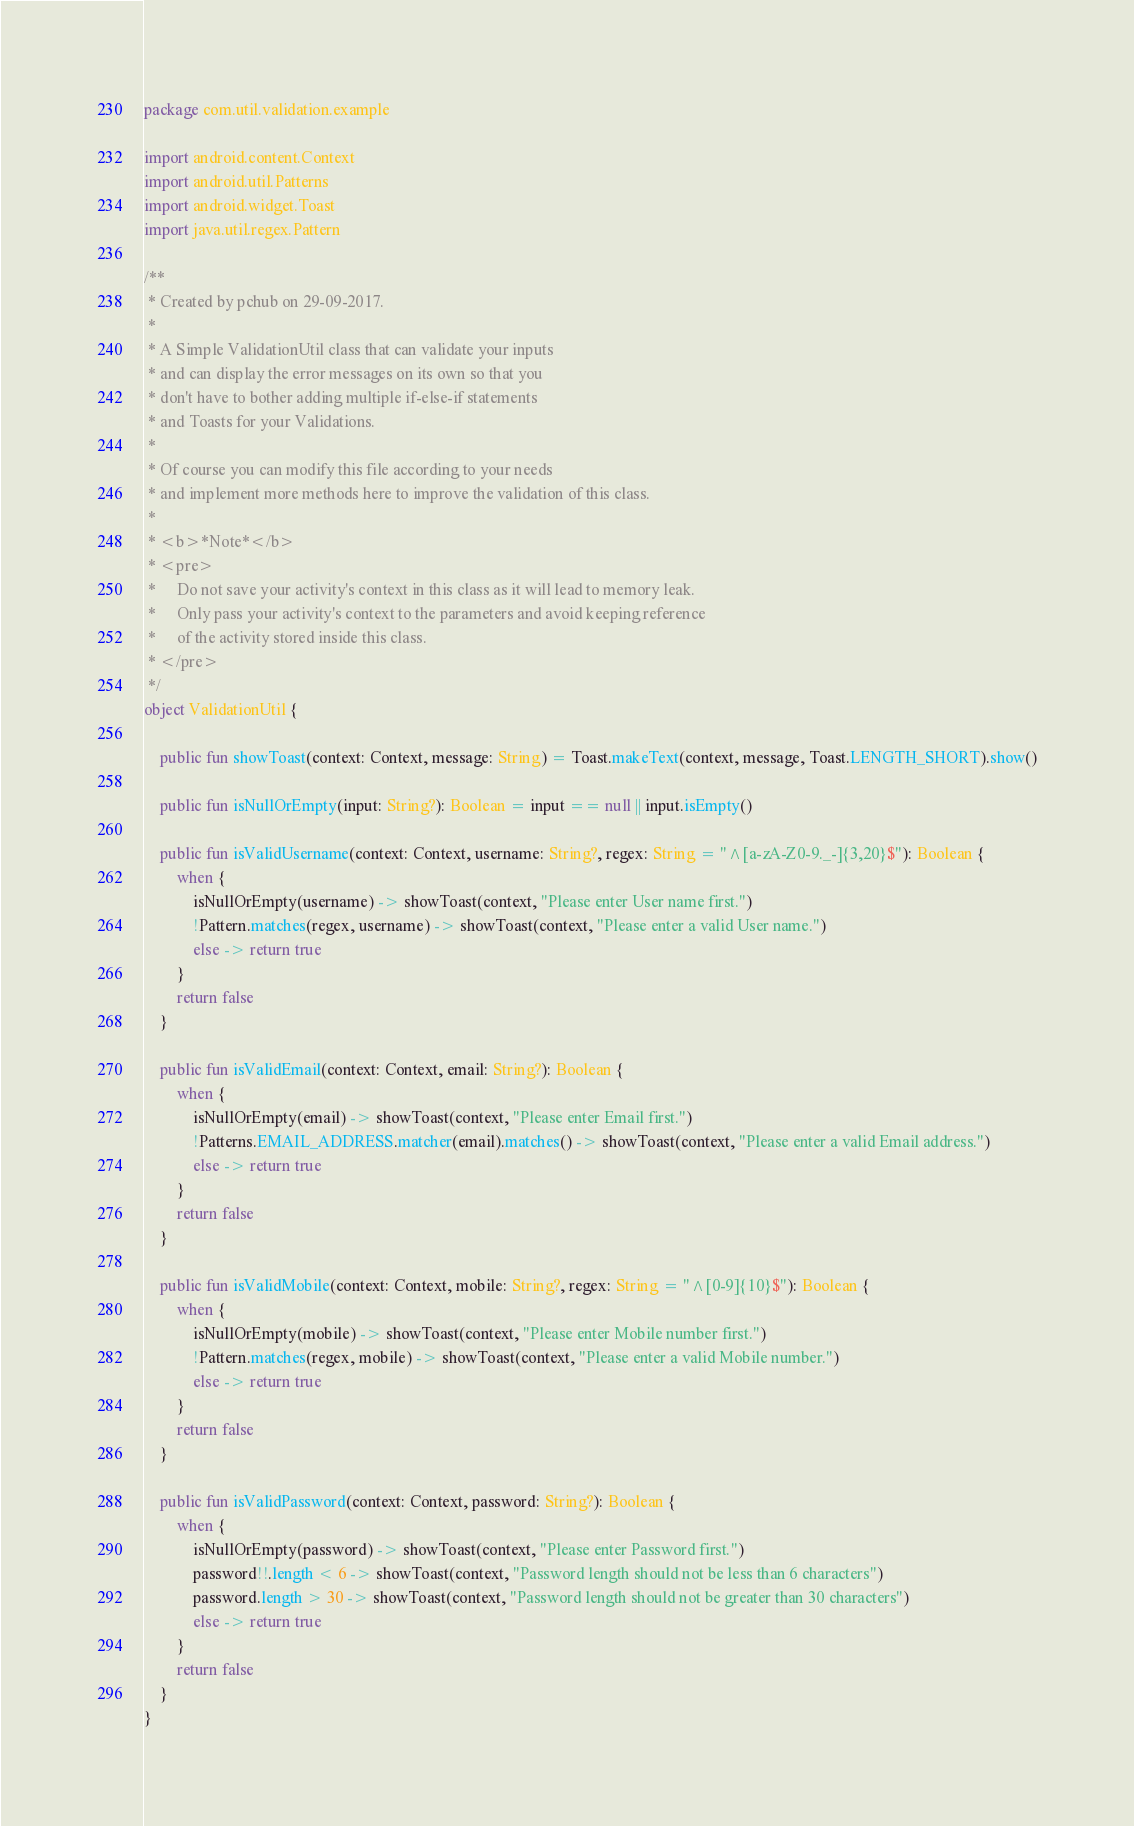<code> <loc_0><loc_0><loc_500><loc_500><_Kotlin_>package com.util.validation.example

import android.content.Context
import android.util.Patterns
import android.widget.Toast
import java.util.regex.Pattern

/**
 * Created by pchub on 29-09-2017.
 *
 * A Simple ValidationUtil class that can validate your inputs
 * and can display the error messages on its own so that you
 * don't have to bother adding multiple if-else-if statements
 * and Toasts for your Validations.
 *
 * Of course you can modify this file according to your needs
 * and implement more methods here to improve the validation of this class.
 *
 * <b>*Note*</b>
 * <pre>
 *     Do not save your activity's context in this class as it will lead to memory leak.
 *     Only pass your activity's context to the parameters and avoid keeping reference
 *     of the activity stored inside this class.
 * </pre>
 */
object ValidationUtil {

    public fun showToast(context: Context, message: String) = Toast.makeText(context, message, Toast.LENGTH_SHORT).show()

    public fun isNullOrEmpty(input: String?): Boolean = input == null || input.isEmpty()

    public fun isValidUsername(context: Context, username: String?, regex: String = "^[a-zA-Z0-9._-]{3,20}$"): Boolean {
        when {
            isNullOrEmpty(username) -> showToast(context, "Please enter User name first.")
            !Pattern.matches(regex, username) -> showToast(context, "Please enter a valid User name.")
            else -> return true
        }
        return false
    }

    public fun isValidEmail(context: Context, email: String?): Boolean {
        when {
            isNullOrEmpty(email) -> showToast(context, "Please enter Email first.")
            !Patterns.EMAIL_ADDRESS.matcher(email).matches() -> showToast(context, "Please enter a valid Email address.")
            else -> return true
        }
        return false
    }

    public fun isValidMobile(context: Context, mobile: String?, regex: String = "^[0-9]{10}$"): Boolean {
        when {
            isNullOrEmpty(mobile) -> showToast(context, "Please enter Mobile number first.")
            !Pattern.matches(regex, mobile) -> showToast(context, "Please enter a valid Mobile number.")
            else -> return true
        }
        return false
    }

    public fun isValidPassword(context: Context, password: String?): Boolean {
        when {
            isNullOrEmpty(password) -> showToast(context, "Please enter Password first.")
            password!!.length < 6 -> showToast(context, "Password length should not be less than 6 characters")
            password.length > 30 -> showToast(context, "Password length should not be greater than 30 characters")
            else -> return true
        }
        return false
    }
}</code> 